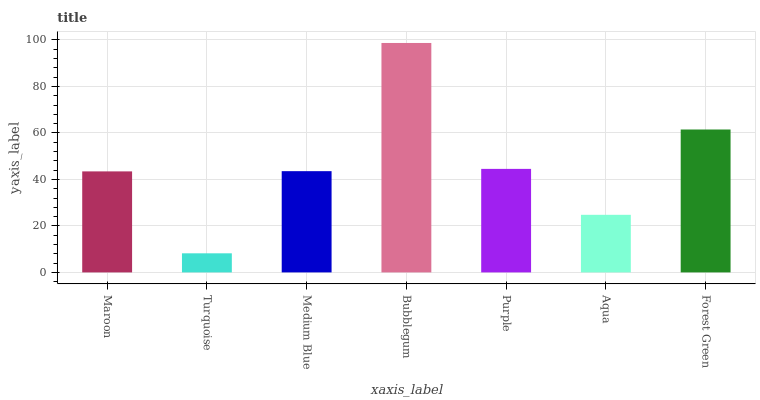Is Turquoise the minimum?
Answer yes or no. Yes. Is Bubblegum the maximum?
Answer yes or no. Yes. Is Medium Blue the minimum?
Answer yes or no. No. Is Medium Blue the maximum?
Answer yes or no. No. Is Medium Blue greater than Turquoise?
Answer yes or no. Yes. Is Turquoise less than Medium Blue?
Answer yes or no. Yes. Is Turquoise greater than Medium Blue?
Answer yes or no. No. Is Medium Blue less than Turquoise?
Answer yes or no. No. Is Medium Blue the high median?
Answer yes or no. Yes. Is Medium Blue the low median?
Answer yes or no. Yes. Is Purple the high median?
Answer yes or no. No. Is Forest Green the low median?
Answer yes or no. No. 